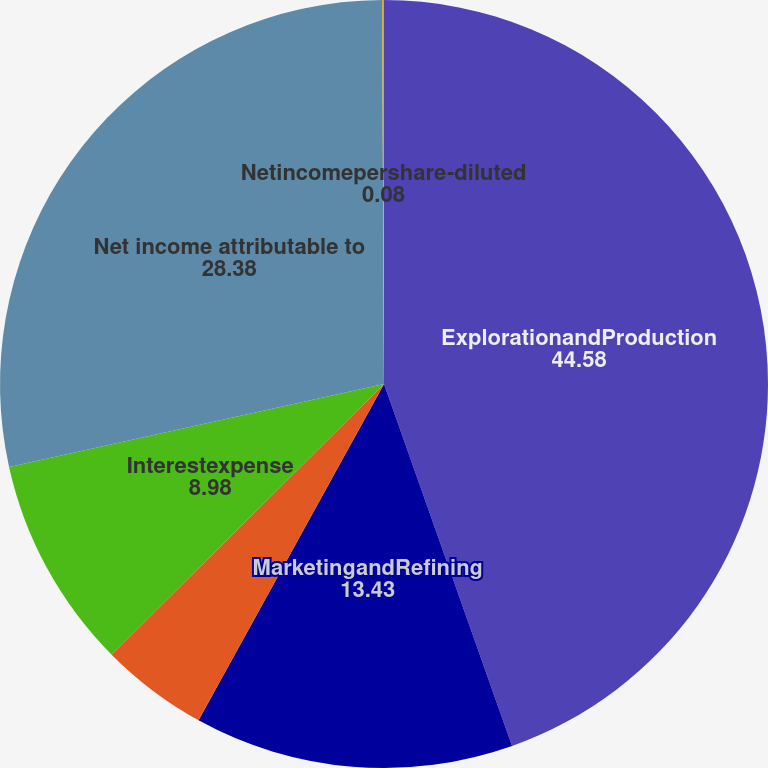Convert chart to OTSL. <chart><loc_0><loc_0><loc_500><loc_500><pie_chart><fcel>ExplorationandProduction<fcel>MarketingandRefining<fcel>Corporate<fcel>Interestexpense<fcel>Net income attributable to<fcel>Netincomepershare-diluted<nl><fcel>44.58%<fcel>13.43%<fcel>4.53%<fcel>8.98%<fcel>28.38%<fcel>0.08%<nl></chart> 